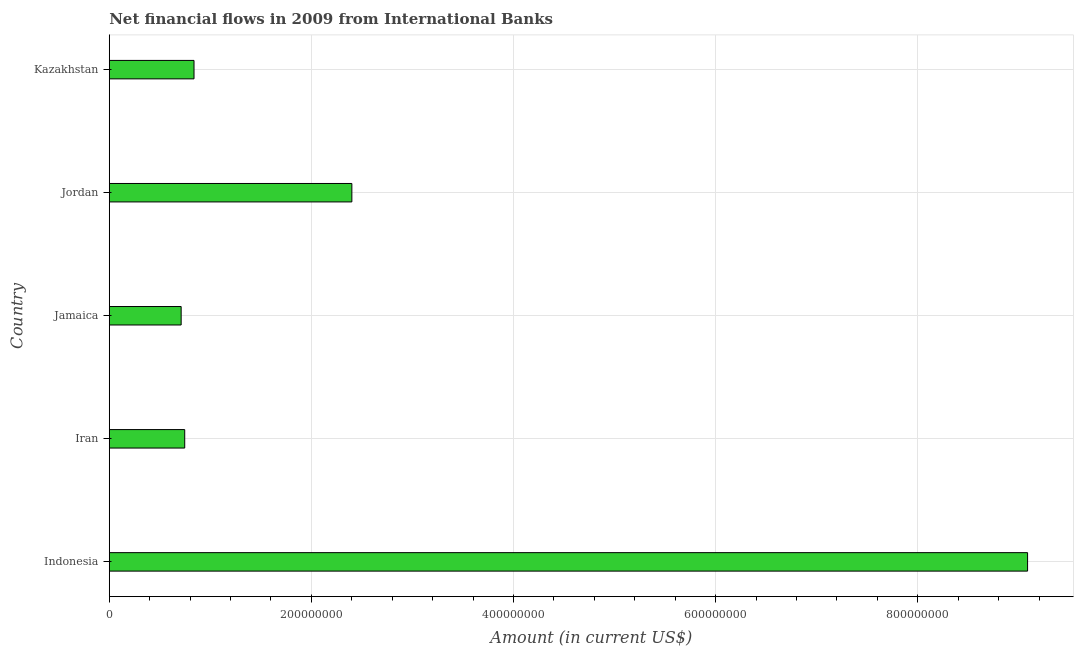What is the title of the graph?
Ensure brevity in your answer.  Net financial flows in 2009 from International Banks. What is the label or title of the X-axis?
Provide a short and direct response. Amount (in current US$). What is the label or title of the Y-axis?
Your response must be concise. Country. What is the net financial flows from ibrd in Jordan?
Make the answer very short. 2.40e+08. Across all countries, what is the maximum net financial flows from ibrd?
Keep it short and to the point. 9.09e+08. Across all countries, what is the minimum net financial flows from ibrd?
Make the answer very short. 7.11e+07. In which country was the net financial flows from ibrd maximum?
Keep it short and to the point. Indonesia. In which country was the net financial flows from ibrd minimum?
Keep it short and to the point. Jamaica. What is the sum of the net financial flows from ibrd?
Make the answer very short. 1.38e+09. What is the difference between the net financial flows from ibrd in Iran and Jamaica?
Offer a terse response. 3.54e+06. What is the average net financial flows from ibrd per country?
Your answer should be compact. 2.76e+08. What is the median net financial flows from ibrd?
Ensure brevity in your answer.  8.38e+07. In how many countries, is the net financial flows from ibrd greater than 160000000 US$?
Your response must be concise. 2. What is the ratio of the net financial flows from ibrd in Indonesia to that in Kazakhstan?
Keep it short and to the point. 10.84. What is the difference between the highest and the second highest net financial flows from ibrd?
Provide a succinct answer. 6.69e+08. Is the sum of the net financial flows from ibrd in Iran and Kazakhstan greater than the maximum net financial flows from ibrd across all countries?
Make the answer very short. No. What is the difference between the highest and the lowest net financial flows from ibrd?
Provide a short and direct response. 8.37e+08. In how many countries, is the net financial flows from ibrd greater than the average net financial flows from ibrd taken over all countries?
Ensure brevity in your answer.  1. How many bars are there?
Offer a terse response. 5. Are all the bars in the graph horizontal?
Give a very brief answer. Yes. How many countries are there in the graph?
Provide a succinct answer. 5. What is the difference between two consecutive major ticks on the X-axis?
Provide a short and direct response. 2.00e+08. Are the values on the major ticks of X-axis written in scientific E-notation?
Make the answer very short. No. What is the Amount (in current US$) of Indonesia?
Make the answer very short. 9.09e+08. What is the Amount (in current US$) of Iran?
Provide a short and direct response. 7.47e+07. What is the Amount (in current US$) in Jamaica?
Offer a very short reply. 7.11e+07. What is the Amount (in current US$) of Jordan?
Provide a succinct answer. 2.40e+08. What is the Amount (in current US$) in Kazakhstan?
Your answer should be very brief. 8.38e+07. What is the difference between the Amount (in current US$) in Indonesia and Iran?
Provide a short and direct response. 8.34e+08. What is the difference between the Amount (in current US$) in Indonesia and Jamaica?
Ensure brevity in your answer.  8.37e+08. What is the difference between the Amount (in current US$) in Indonesia and Jordan?
Offer a very short reply. 6.69e+08. What is the difference between the Amount (in current US$) in Indonesia and Kazakhstan?
Your response must be concise. 8.25e+08. What is the difference between the Amount (in current US$) in Iran and Jamaica?
Your response must be concise. 3.54e+06. What is the difference between the Amount (in current US$) in Iran and Jordan?
Offer a very short reply. -1.65e+08. What is the difference between the Amount (in current US$) in Iran and Kazakhstan?
Offer a very short reply. -9.18e+06. What is the difference between the Amount (in current US$) in Jamaica and Jordan?
Give a very brief answer. -1.69e+08. What is the difference between the Amount (in current US$) in Jamaica and Kazakhstan?
Your answer should be compact. -1.27e+07. What is the difference between the Amount (in current US$) in Jordan and Kazakhstan?
Offer a very short reply. 1.56e+08. What is the ratio of the Amount (in current US$) in Indonesia to that in Iran?
Ensure brevity in your answer.  12.17. What is the ratio of the Amount (in current US$) in Indonesia to that in Jamaica?
Give a very brief answer. 12.78. What is the ratio of the Amount (in current US$) in Indonesia to that in Jordan?
Ensure brevity in your answer.  3.79. What is the ratio of the Amount (in current US$) in Indonesia to that in Kazakhstan?
Provide a succinct answer. 10.84. What is the ratio of the Amount (in current US$) in Iran to that in Jordan?
Offer a terse response. 0.31. What is the ratio of the Amount (in current US$) in Iran to that in Kazakhstan?
Your answer should be compact. 0.89. What is the ratio of the Amount (in current US$) in Jamaica to that in Jordan?
Your answer should be compact. 0.3. What is the ratio of the Amount (in current US$) in Jamaica to that in Kazakhstan?
Keep it short and to the point. 0.85. What is the ratio of the Amount (in current US$) in Jordan to that in Kazakhstan?
Give a very brief answer. 2.86. 